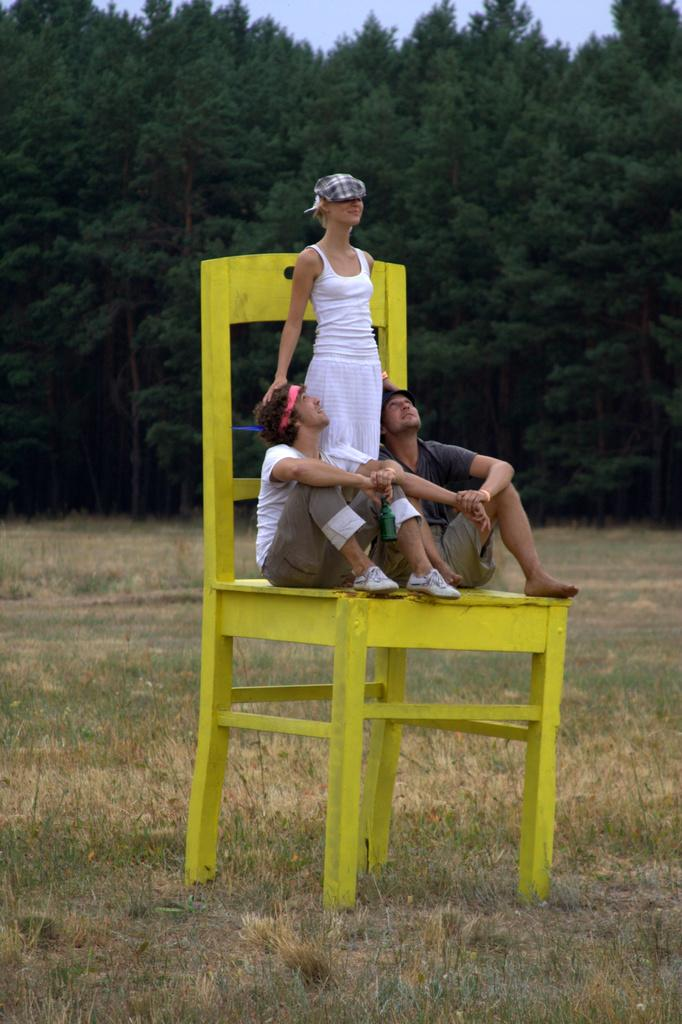How many people are in the image? There are three people in the image: one woman and two men. What are the people in the image doing? The woman and men are sitting on a chair. What type of vegetation is visible in the image? There is grass in the image. What can be seen in the background of the image? There are trees and the sky visible in the background of the image. What decision is being made by the sign in the image? There is no sign present in the image, so no decision can be made by a sign. 